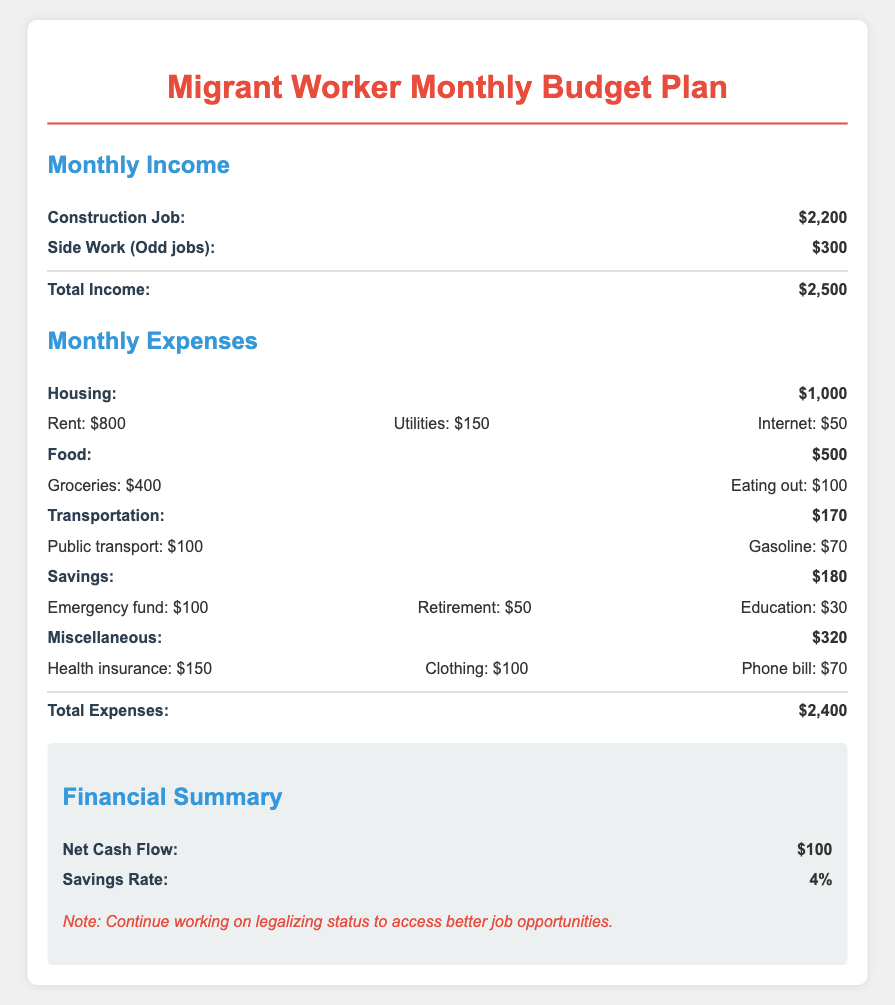What is the total income? The total income is calculated by adding the construction job income and side work income, which are $2,200 and $300, respectively.
Answer: $2,500 What is the monthly expense for food? The expense for food is specified separately, which sums up to $500.
Answer: $500 How much is allocated for housing? The budget shows that the cost for housing is explicitly stated as $1,000.
Answer: $1,000 What is the amount for savings? The budget listed under savings sums to $180, covering various saving categories.
Answer: $180 What is the net cash flow? The net cash flow is derived from total income minus total expenses, which results in $100.
Answer: $100 What percentage is the savings rate? The document states the savings rate, which is represented as a percentage: 4%.
Answer: 4% How much is spent on transportation? The total transportation expense is detailed and amounts to $170.
Answer: $170 What is included in the miscellaneous category? The miscellaneous category comprises health insurance, clothing, and phone bill costs totaling $320.
Answer: $320 What is the total expense amount? The total expenses are summed up in the document, showing an amount of $2,400.
Answer: $2,400 